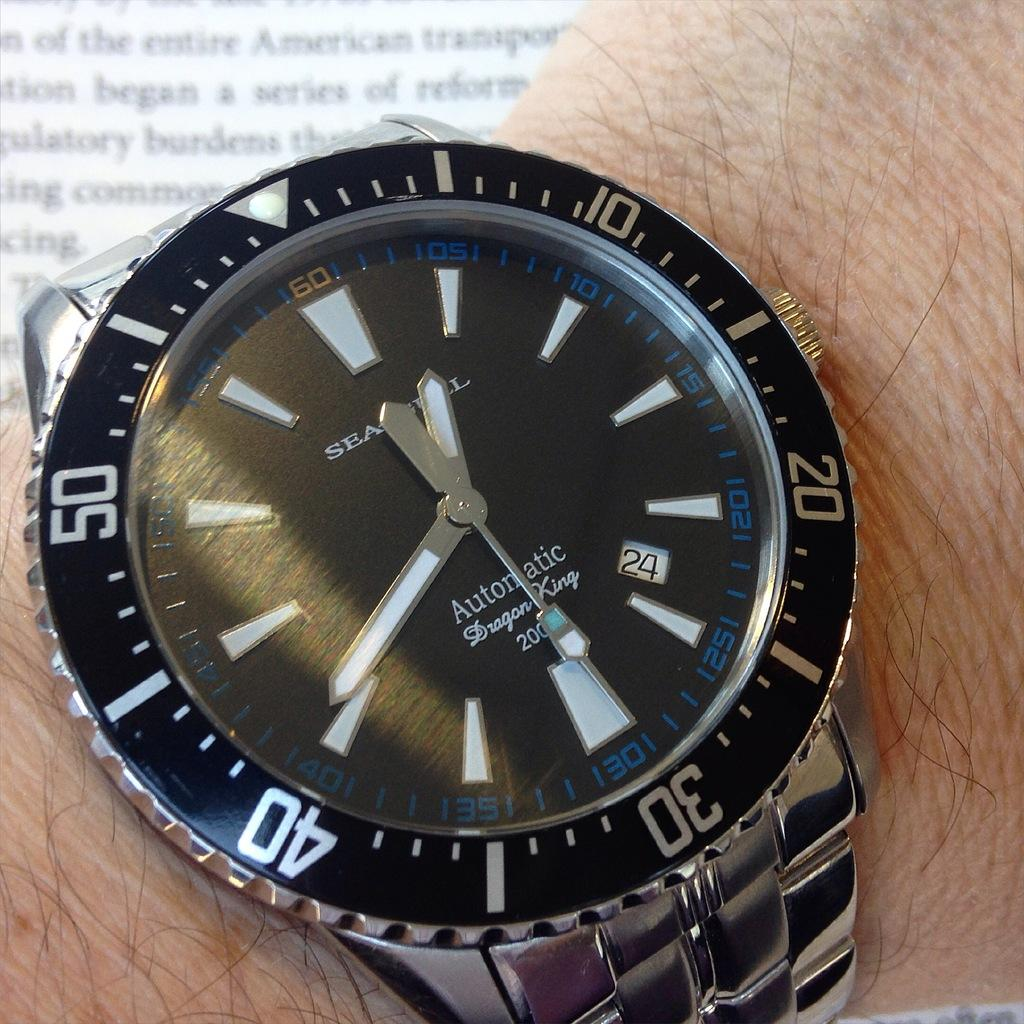<image>
Render a clear and concise summary of the photo. A close up view of a watch that reads "Automatic" on a man's wrist. 